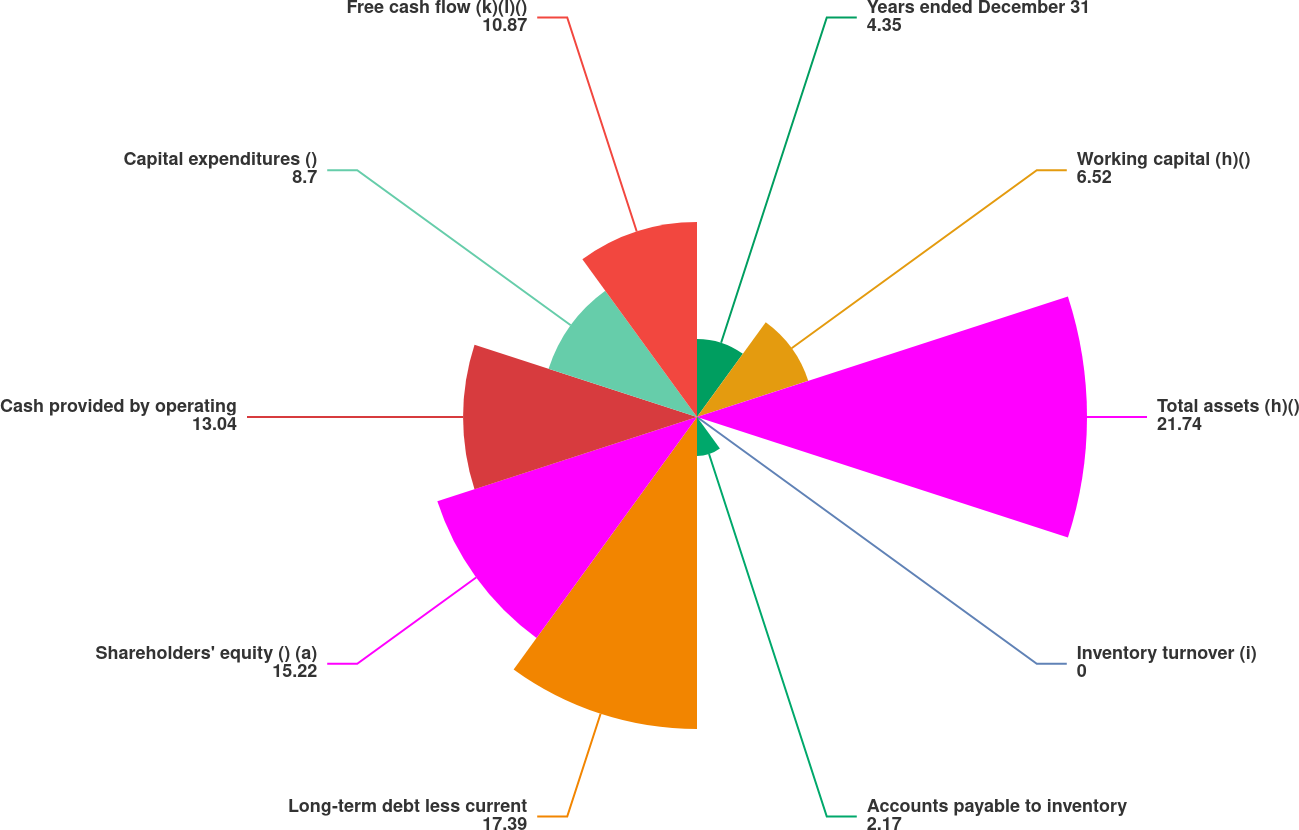Convert chart to OTSL. <chart><loc_0><loc_0><loc_500><loc_500><pie_chart><fcel>Years ended December 31<fcel>Working capital (h)()<fcel>Total assets (h)()<fcel>Inventory turnover (i)<fcel>Accounts payable to inventory<fcel>Long-term debt less current<fcel>Shareholders' equity () (a)<fcel>Cash provided by operating<fcel>Capital expenditures ()<fcel>Free cash flow (k)(l)()<nl><fcel>4.35%<fcel>6.52%<fcel>21.74%<fcel>0.0%<fcel>2.17%<fcel>17.39%<fcel>15.22%<fcel>13.04%<fcel>8.7%<fcel>10.87%<nl></chart> 